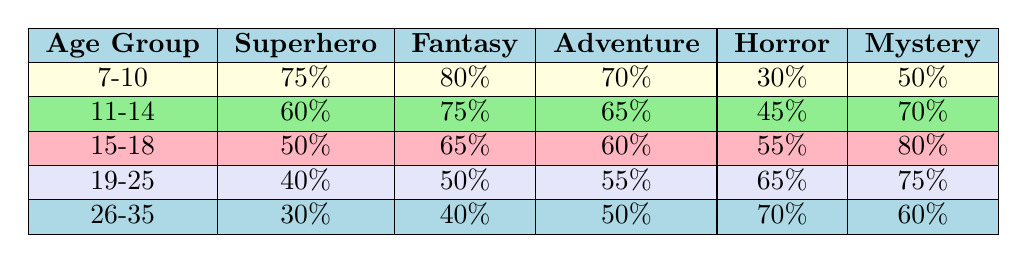What age group has the highest preference for the Fantasy genre? According to the table, the age group 7-10 has the highest preference for the Fantasy genre at 80%.
Answer: 7-10 Which genre is least popular among the 26-35 age group? In the 26-35 age group, the Superhero genre is the least popular with a preference of 30%.
Answer: Superhero What is the average popularity of the Horror genre across all age groups? To find the average, sum the preferences for the Horror genre: (30 + 45 + 55 + 65 + 70) = 265. There are 5 age groups, so the average is 265/5 = 53.
Answer: 53 Is the preference for the Mystery genre increasing with age? Comparing the preferences for the Mystery genre: 50%, 70%, 80%, 75%, and 60%, it shows both an increase and decrease, so it is not consistently increasing.
Answer: No In the 15-18 age group, how does the Adventure genre popularity compare to that of the Superhero genre? The Adventure genre has a popularity of 60%, while the Superhero genre has a popularity of 50%. Therefore, the Adventure genre is more popular than Superhero by a margin of 10%.
Answer: Adventure is more popular Which age group has the lowest preference for the Adventure genre? The age group 26-35 has the lowest preference for the Adventure genre at 50%.
Answer: 26-35 What is the difference in percentage preference for the Superhero genre between the 11-14 and 15-18 age groups? The Superhero genre has a preference of 60% in the 11-14 age group and 50% in the 15-18 age group. The difference is 60% - 50% = 10%.
Answer: 10% Which genre is twice as popular in the 7-10 age group compared to the Horror genre in the same group? The Horror genre is 30% in the 7-10 age group. Twice this value is 60%. The Superhero genre at 75% is the only one exceeding this threshold.
Answer: Superhero genre Is there any age group that has a higher preference for Horror than Superhero? Yes, the 19-25 and 26-35 age groups prefer the Horror genre (65% and 70%) more than the Superhero genre (40% and 30% respectively).
Answer: Yes 